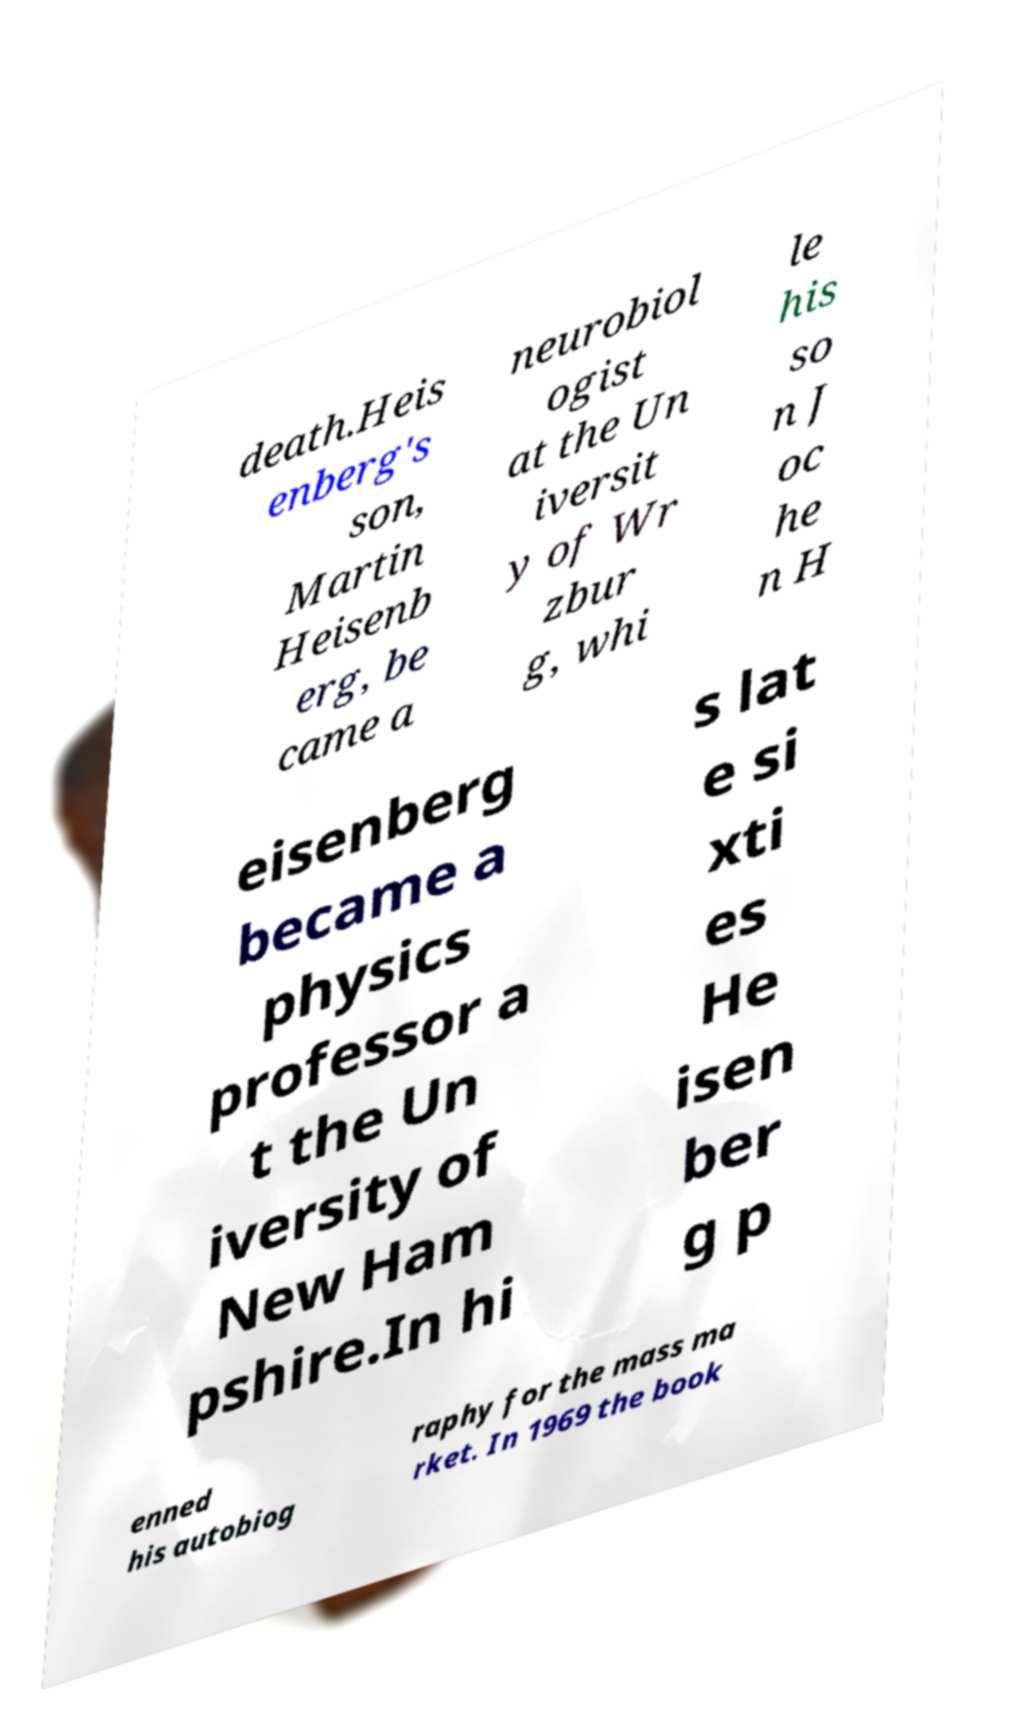For documentation purposes, I need the text within this image transcribed. Could you provide that? death.Heis enberg's son, Martin Heisenb erg, be came a neurobiol ogist at the Un iversit y of Wr zbur g, whi le his so n J oc he n H eisenberg became a physics professor a t the Un iversity of New Ham pshire.In hi s lat e si xti es He isen ber g p enned his autobiog raphy for the mass ma rket. In 1969 the book 